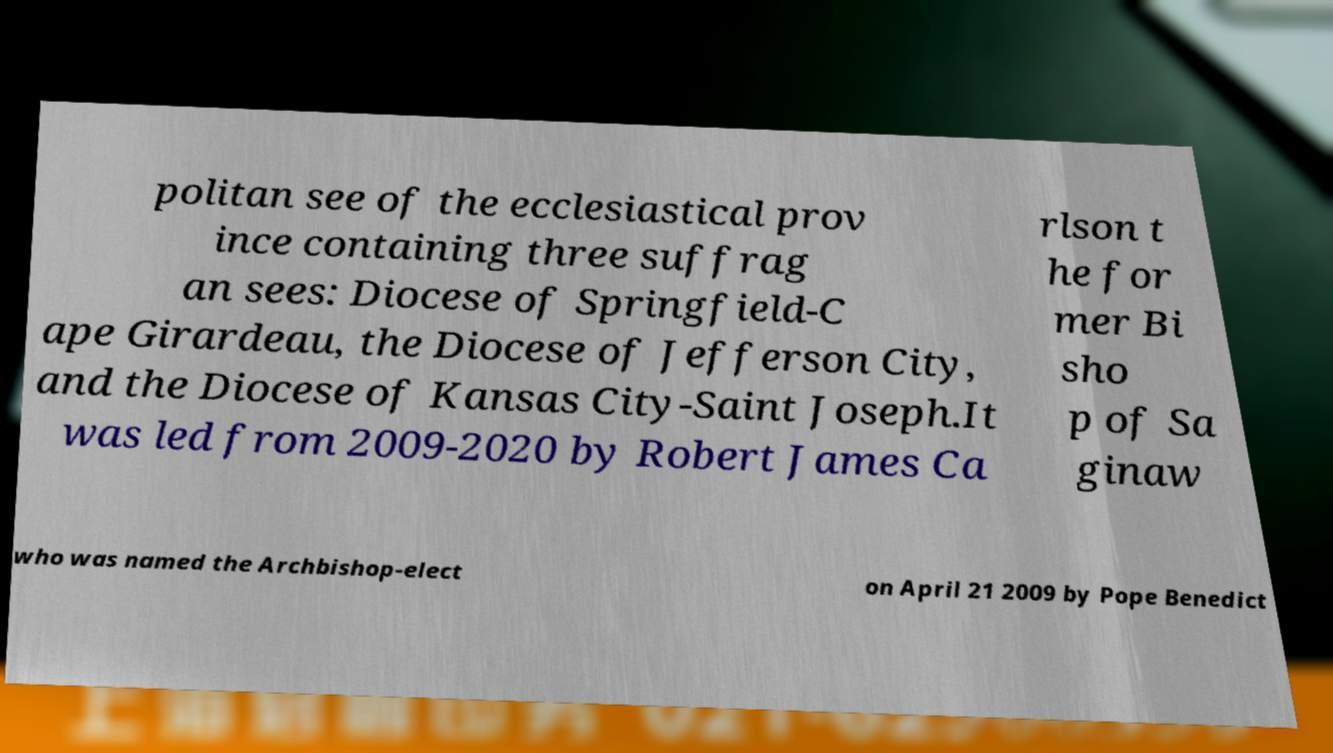Can you read and provide the text displayed in the image?This photo seems to have some interesting text. Can you extract and type it out for me? politan see of the ecclesiastical prov ince containing three suffrag an sees: Diocese of Springfield-C ape Girardeau, the Diocese of Jefferson City, and the Diocese of Kansas City-Saint Joseph.It was led from 2009-2020 by Robert James Ca rlson t he for mer Bi sho p of Sa ginaw who was named the Archbishop-elect on April 21 2009 by Pope Benedict 